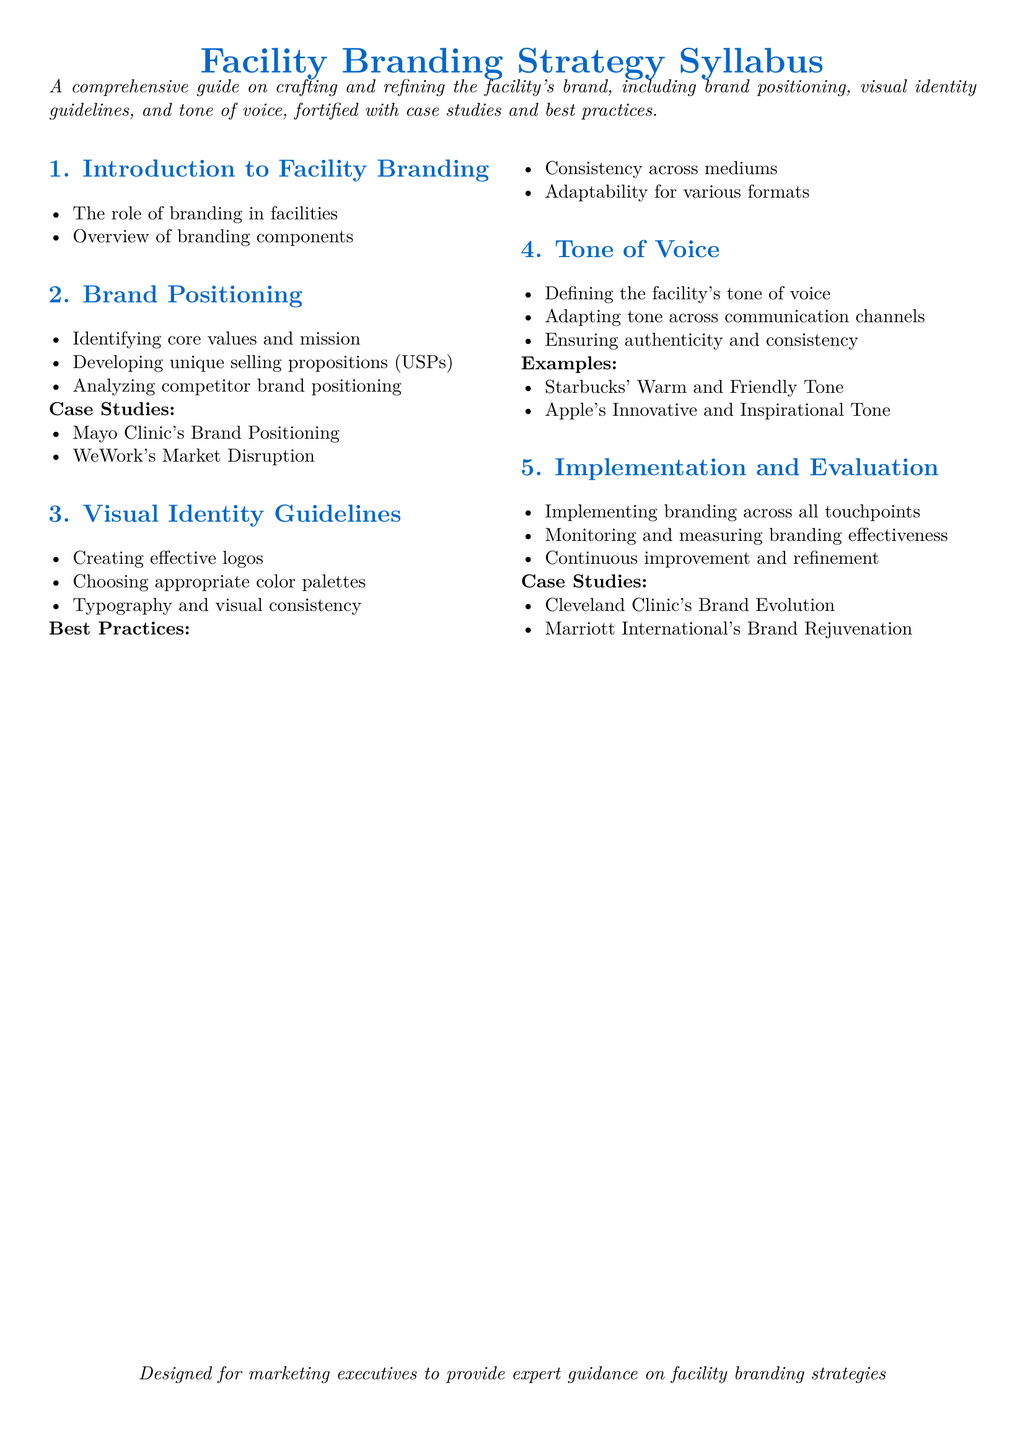What are the components of branding mentioned? The document lists an overview of branding components as part of the introduction section.
Answer: Branding components What are the case studies included in brand positioning? The document mentions specific case studies in the brand positioning section to illustrate effective branding.
Answer: Mayo Clinic's Brand Positioning, WeWork's Market Disruption What are the visual identity guidelines discussed? This refers to the section specifically dedicated to creating and maintaining visual branding elements.
Answer: Creating effective logos, Choosing appropriate color palettes, Typography and visual consistency Which two brands exemplify the tone of voice examples? The document provides examples from well-known brands in the tone of voice section.
Answer: Starbucks, Apple How many sections are there in the syllabus? The document organizes the content into distinct sections, which can be counted.
Answer: Five 